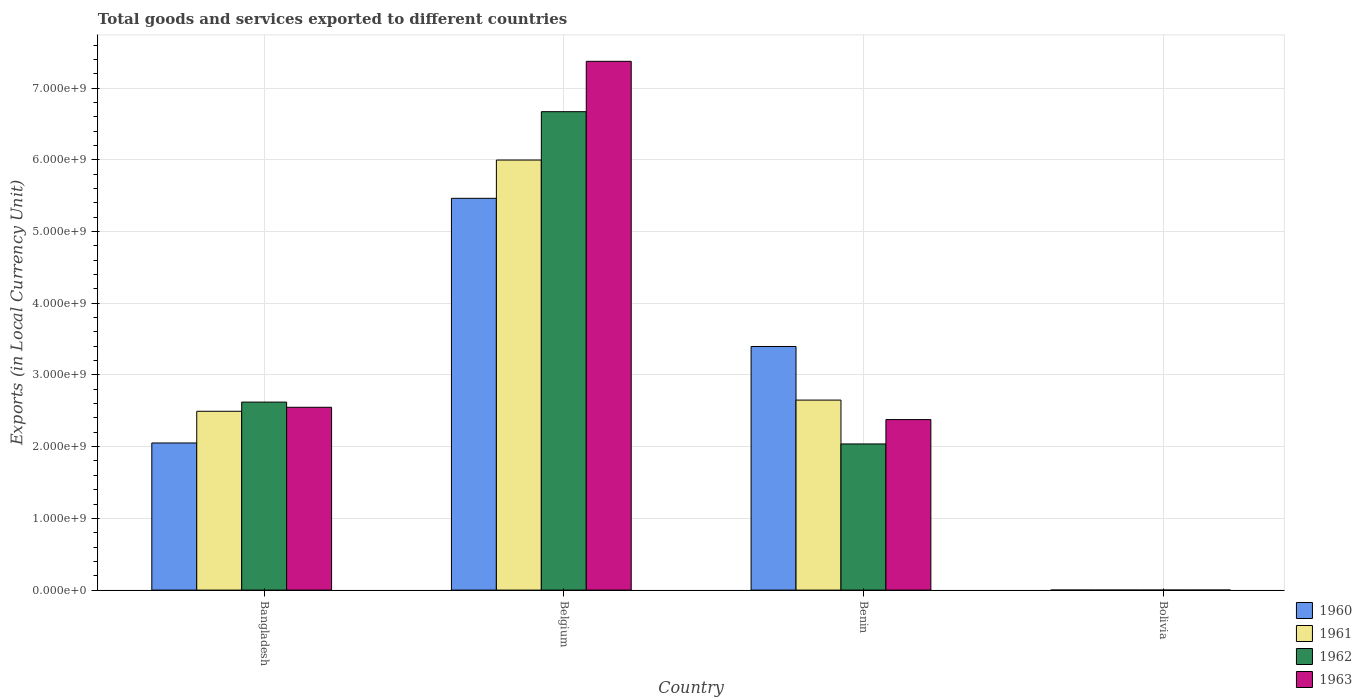How many groups of bars are there?
Your answer should be very brief. 4. Are the number of bars per tick equal to the number of legend labels?
Ensure brevity in your answer.  Yes. Are the number of bars on each tick of the X-axis equal?
Provide a short and direct response. Yes. How many bars are there on the 3rd tick from the left?
Make the answer very short. 4. In how many cases, is the number of bars for a given country not equal to the number of legend labels?
Keep it short and to the point. 0. What is the Amount of goods and services exports in 1960 in Bangladesh?
Provide a short and direct response. 2.05e+09. Across all countries, what is the maximum Amount of goods and services exports in 1962?
Your answer should be compact. 6.67e+09. Across all countries, what is the minimum Amount of goods and services exports in 1961?
Offer a very short reply. 1000. In which country was the Amount of goods and services exports in 1963 minimum?
Make the answer very short. Bolivia. What is the total Amount of goods and services exports in 1962 in the graph?
Provide a succinct answer. 1.13e+1. What is the difference between the Amount of goods and services exports in 1962 in Benin and that in Bolivia?
Your answer should be very brief. 2.04e+09. What is the difference between the Amount of goods and services exports in 1961 in Benin and the Amount of goods and services exports in 1960 in Bangladesh?
Your answer should be compact. 5.98e+08. What is the average Amount of goods and services exports in 1961 per country?
Keep it short and to the point. 2.78e+09. What is the difference between the Amount of goods and services exports of/in 1961 and Amount of goods and services exports of/in 1960 in Bangladesh?
Give a very brief answer. 4.42e+08. In how many countries, is the Amount of goods and services exports in 1961 greater than 4200000000 LCU?
Ensure brevity in your answer.  1. What is the ratio of the Amount of goods and services exports in 1963 in Benin to that in Bolivia?
Provide a short and direct response. 1.98e+06. Is the Amount of goods and services exports in 1960 in Belgium less than that in Bolivia?
Your answer should be compact. No. What is the difference between the highest and the second highest Amount of goods and services exports in 1962?
Your response must be concise. 4.63e+09. What is the difference between the highest and the lowest Amount of goods and services exports in 1960?
Give a very brief answer. 5.46e+09. Is it the case that in every country, the sum of the Amount of goods and services exports in 1961 and Amount of goods and services exports in 1962 is greater than the sum of Amount of goods and services exports in 1960 and Amount of goods and services exports in 1963?
Provide a succinct answer. No. What does the 2nd bar from the left in Bolivia represents?
Your answer should be very brief. 1961. Are all the bars in the graph horizontal?
Make the answer very short. No. Are the values on the major ticks of Y-axis written in scientific E-notation?
Your response must be concise. Yes. Does the graph contain any zero values?
Ensure brevity in your answer.  No. What is the title of the graph?
Your response must be concise. Total goods and services exported to different countries. What is the label or title of the Y-axis?
Make the answer very short. Exports (in Local Currency Unit). What is the Exports (in Local Currency Unit) of 1960 in Bangladesh?
Offer a very short reply. 2.05e+09. What is the Exports (in Local Currency Unit) of 1961 in Bangladesh?
Offer a terse response. 2.49e+09. What is the Exports (in Local Currency Unit) of 1962 in Bangladesh?
Offer a very short reply. 2.62e+09. What is the Exports (in Local Currency Unit) of 1963 in Bangladesh?
Provide a succinct answer. 2.55e+09. What is the Exports (in Local Currency Unit) in 1960 in Belgium?
Offer a terse response. 5.46e+09. What is the Exports (in Local Currency Unit) of 1961 in Belgium?
Keep it short and to the point. 6.00e+09. What is the Exports (in Local Currency Unit) in 1962 in Belgium?
Offer a very short reply. 6.67e+09. What is the Exports (in Local Currency Unit) in 1963 in Belgium?
Offer a very short reply. 7.37e+09. What is the Exports (in Local Currency Unit) of 1960 in Benin?
Your answer should be very brief. 3.40e+09. What is the Exports (in Local Currency Unit) of 1961 in Benin?
Give a very brief answer. 2.65e+09. What is the Exports (in Local Currency Unit) of 1962 in Benin?
Make the answer very short. 2.04e+09. What is the Exports (in Local Currency Unit) of 1963 in Benin?
Ensure brevity in your answer.  2.38e+09. What is the Exports (in Local Currency Unit) of 1960 in Bolivia?
Give a very brief answer. 900. What is the Exports (in Local Currency Unit) in 1962 in Bolivia?
Your response must be concise. 1000. What is the Exports (in Local Currency Unit) in 1963 in Bolivia?
Your answer should be very brief. 1200. Across all countries, what is the maximum Exports (in Local Currency Unit) of 1960?
Your answer should be very brief. 5.46e+09. Across all countries, what is the maximum Exports (in Local Currency Unit) of 1961?
Your response must be concise. 6.00e+09. Across all countries, what is the maximum Exports (in Local Currency Unit) in 1962?
Keep it short and to the point. 6.67e+09. Across all countries, what is the maximum Exports (in Local Currency Unit) in 1963?
Ensure brevity in your answer.  7.37e+09. Across all countries, what is the minimum Exports (in Local Currency Unit) of 1960?
Offer a very short reply. 900. Across all countries, what is the minimum Exports (in Local Currency Unit) of 1961?
Provide a succinct answer. 1000. Across all countries, what is the minimum Exports (in Local Currency Unit) in 1962?
Provide a succinct answer. 1000. Across all countries, what is the minimum Exports (in Local Currency Unit) in 1963?
Your answer should be compact. 1200. What is the total Exports (in Local Currency Unit) in 1960 in the graph?
Give a very brief answer. 1.09e+1. What is the total Exports (in Local Currency Unit) in 1961 in the graph?
Offer a terse response. 1.11e+1. What is the total Exports (in Local Currency Unit) of 1962 in the graph?
Your answer should be very brief. 1.13e+1. What is the total Exports (in Local Currency Unit) in 1963 in the graph?
Your response must be concise. 1.23e+1. What is the difference between the Exports (in Local Currency Unit) of 1960 in Bangladesh and that in Belgium?
Your response must be concise. -3.41e+09. What is the difference between the Exports (in Local Currency Unit) in 1961 in Bangladesh and that in Belgium?
Keep it short and to the point. -3.50e+09. What is the difference between the Exports (in Local Currency Unit) in 1962 in Bangladesh and that in Belgium?
Your answer should be compact. -4.05e+09. What is the difference between the Exports (in Local Currency Unit) in 1963 in Bangladesh and that in Belgium?
Offer a very short reply. -4.82e+09. What is the difference between the Exports (in Local Currency Unit) in 1960 in Bangladesh and that in Benin?
Offer a terse response. -1.35e+09. What is the difference between the Exports (in Local Currency Unit) of 1961 in Bangladesh and that in Benin?
Provide a short and direct response. -1.56e+08. What is the difference between the Exports (in Local Currency Unit) in 1962 in Bangladesh and that in Benin?
Your answer should be compact. 5.83e+08. What is the difference between the Exports (in Local Currency Unit) in 1963 in Bangladesh and that in Benin?
Keep it short and to the point. 1.72e+08. What is the difference between the Exports (in Local Currency Unit) of 1960 in Bangladesh and that in Bolivia?
Provide a short and direct response. 2.05e+09. What is the difference between the Exports (in Local Currency Unit) of 1961 in Bangladesh and that in Bolivia?
Your answer should be very brief. 2.49e+09. What is the difference between the Exports (in Local Currency Unit) in 1962 in Bangladesh and that in Bolivia?
Offer a very short reply. 2.62e+09. What is the difference between the Exports (in Local Currency Unit) of 1963 in Bangladesh and that in Bolivia?
Your answer should be compact. 2.55e+09. What is the difference between the Exports (in Local Currency Unit) of 1960 in Belgium and that in Benin?
Your answer should be compact. 2.07e+09. What is the difference between the Exports (in Local Currency Unit) in 1961 in Belgium and that in Benin?
Provide a succinct answer. 3.35e+09. What is the difference between the Exports (in Local Currency Unit) of 1962 in Belgium and that in Benin?
Offer a terse response. 4.63e+09. What is the difference between the Exports (in Local Currency Unit) of 1963 in Belgium and that in Benin?
Your response must be concise. 5.00e+09. What is the difference between the Exports (in Local Currency Unit) of 1960 in Belgium and that in Bolivia?
Keep it short and to the point. 5.46e+09. What is the difference between the Exports (in Local Currency Unit) in 1961 in Belgium and that in Bolivia?
Your answer should be very brief. 6.00e+09. What is the difference between the Exports (in Local Currency Unit) in 1962 in Belgium and that in Bolivia?
Make the answer very short. 6.67e+09. What is the difference between the Exports (in Local Currency Unit) in 1963 in Belgium and that in Bolivia?
Your answer should be compact. 7.37e+09. What is the difference between the Exports (in Local Currency Unit) in 1960 in Benin and that in Bolivia?
Provide a short and direct response. 3.40e+09. What is the difference between the Exports (in Local Currency Unit) in 1961 in Benin and that in Bolivia?
Make the answer very short. 2.65e+09. What is the difference between the Exports (in Local Currency Unit) of 1962 in Benin and that in Bolivia?
Offer a terse response. 2.04e+09. What is the difference between the Exports (in Local Currency Unit) of 1963 in Benin and that in Bolivia?
Offer a terse response. 2.38e+09. What is the difference between the Exports (in Local Currency Unit) in 1960 in Bangladesh and the Exports (in Local Currency Unit) in 1961 in Belgium?
Give a very brief answer. -3.94e+09. What is the difference between the Exports (in Local Currency Unit) of 1960 in Bangladesh and the Exports (in Local Currency Unit) of 1962 in Belgium?
Your answer should be very brief. -4.62e+09. What is the difference between the Exports (in Local Currency Unit) in 1960 in Bangladesh and the Exports (in Local Currency Unit) in 1963 in Belgium?
Provide a succinct answer. -5.32e+09. What is the difference between the Exports (in Local Currency Unit) in 1961 in Bangladesh and the Exports (in Local Currency Unit) in 1962 in Belgium?
Ensure brevity in your answer.  -4.18e+09. What is the difference between the Exports (in Local Currency Unit) of 1961 in Bangladesh and the Exports (in Local Currency Unit) of 1963 in Belgium?
Your response must be concise. -4.88e+09. What is the difference between the Exports (in Local Currency Unit) in 1962 in Bangladesh and the Exports (in Local Currency Unit) in 1963 in Belgium?
Give a very brief answer. -4.75e+09. What is the difference between the Exports (in Local Currency Unit) of 1960 in Bangladesh and the Exports (in Local Currency Unit) of 1961 in Benin?
Make the answer very short. -5.98e+08. What is the difference between the Exports (in Local Currency Unit) of 1960 in Bangladesh and the Exports (in Local Currency Unit) of 1962 in Benin?
Make the answer very short. 1.34e+07. What is the difference between the Exports (in Local Currency Unit) of 1960 in Bangladesh and the Exports (in Local Currency Unit) of 1963 in Benin?
Your answer should be compact. -3.26e+08. What is the difference between the Exports (in Local Currency Unit) in 1961 in Bangladesh and the Exports (in Local Currency Unit) in 1962 in Benin?
Keep it short and to the point. 4.55e+08. What is the difference between the Exports (in Local Currency Unit) of 1961 in Bangladesh and the Exports (in Local Currency Unit) of 1963 in Benin?
Ensure brevity in your answer.  1.16e+08. What is the difference between the Exports (in Local Currency Unit) in 1962 in Bangladesh and the Exports (in Local Currency Unit) in 1963 in Benin?
Your response must be concise. 2.44e+08. What is the difference between the Exports (in Local Currency Unit) of 1960 in Bangladesh and the Exports (in Local Currency Unit) of 1961 in Bolivia?
Ensure brevity in your answer.  2.05e+09. What is the difference between the Exports (in Local Currency Unit) in 1960 in Bangladesh and the Exports (in Local Currency Unit) in 1962 in Bolivia?
Your response must be concise. 2.05e+09. What is the difference between the Exports (in Local Currency Unit) in 1960 in Bangladesh and the Exports (in Local Currency Unit) in 1963 in Bolivia?
Offer a terse response. 2.05e+09. What is the difference between the Exports (in Local Currency Unit) of 1961 in Bangladesh and the Exports (in Local Currency Unit) of 1962 in Bolivia?
Keep it short and to the point. 2.49e+09. What is the difference between the Exports (in Local Currency Unit) of 1961 in Bangladesh and the Exports (in Local Currency Unit) of 1963 in Bolivia?
Your answer should be very brief. 2.49e+09. What is the difference between the Exports (in Local Currency Unit) of 1962 in Bangladesh and the Exports (in Local Currency Unit) of 1963 in Bolivia?
Make the answer very short. 2.62e+09. What is the difference between the Exports (in Local Currency Unit) in 1960 in Belgium and the Exports (in Local Currency Unit) in 1961 in Benin?
Your answer should be very brief. 2.81e+09. What is the difference between the Exports (in Local Currency Unit) in 1960 in Belgium and the Exports (in Local Currency Unit) in 1962 in Benin?
Offer a very short reply. 3.42e+09. What is the difference between the Exports (in Local Currency Unit) in 1960 in Belgium and the Exports (in Local Currency Unit) in 1963 in Benin?
Ensure brevity in your answer.  3.08e+09. What is the difference between the Exports (in Local Currency Unit) of 1961 in Belgium and the Exports (in Local Currency Unit) of 1962 in Benin?
Make the answer very short. 3.96e+09. What is the difference between the Exports (in Local Currency Unit) of 1961 in Belgium and the Exports (in Local Currency Unit) of 1963 in Benin?
Give a very brief answer. 3.62e+09. What is the difference between the Exports (in Local Currency Unit) of 1962 in Belgium and the Exports (in Local Currency Unit) of 1963 in Benin?
Provide a succinct answer. 4.29e+09. What is the difference between the Exports (in Local Currency Unit) in 1960 in Belgium and the Exports (in Local Currency Unit) in 1961 in Bolivia?
Your answer should be compact. 5.46e+09. What is the difference between the Exports (in Local Currency Unit) of 1960 in Belgium and the Exports (in Local Currency Unit) of 1962 in Bolivia?
Make the answer very short. 5.46e+09. What is the difference between the Exports (in Local Currency Unit) of 1960 in Belgium and the Exports (in Local Currency Unit) of 1963 in Bolivia?
Offer a terse response. 5.46e+09. What is the difference between the Exports (in Local Currency Unit) in 1961 in Belgium and the Exports (in Local Currency Unit) in 1962 in Bolivia?
Offer a very short reply. 6.00e+09. What is the difference between the Exports (in Local Currency Unit) in 1961 in Belgium and the Exports (in Local Currency Unit) in 1963 in Bolivia?
Give a very brief answer. 6.00e+09. What is the difference between the Exports (in Local Currency Unit) in 1962 in Belgium and the Exports (in Local Currency Unit) in 1963 in Bolivia?
Your response must be concise. 6.67e+09. What is the difference between the Exports (in Local Currency Unit) of 1960 in Benin and the Exports (in Local Currency Unit) of 1961 in Bolivia?
Provide a succinct answer. 3.40e+09. What is the difference between the Exports (in Local Currency Unit) of 1960 in Benin and the Exports (in Local Currency Unit) of 1962 in Bolivia?
Give a very brief answer. 3.40e+09. What is the difference between the Exports (in Local Currency Unit) in 1960 in Benin and the Exports (in Local Currency Unit) in 1963 in Bolivia?
Ensure brevity in your answer.  3.40e+09. What is the difference between the Exports (in Local Currency Unit) in 1961 in Benin and the Exports (in Local Currency Unit) in 1962 in Bolivia?
Make the answer very short. 2.65e+09. What is the difference between the Exports (in Local Currency Unit) of 1961 in Benin and the Exports (in Local Currency Unit) of 1963 in Bolivia?
Your answer should be very brief. 2.65e+09. What is the difference between the Exports (in Local Currency Unit) in 1962 in Benin and the Exports (in Local Currency Unit) in 1963 in Bolivia?
Provide a succinct answer. 2.04e+09. What is the average Exports (in Local Currency Unit) of 1960 per country?
Your answer should be very brief. 2.73e+09. What is the average Exports (in Local Currency Unit) of 1961 per country?
Provide a short and direct response. 2.78e+09. What is the average Exports (in Local Currency Unit) of 1962 per country?
Your response must be concise. 2.83e+09. What is the average Exports (in Local Currency Unit) of 1963 per country?
Give a very brief answer. 3.07e+09. What is the difference between the Exports (in Local Currency Unit) in 1960 and Exports (in Local Currency Unit) in 1961 in Bangladesh?
Give a very brief answer. -4.42e+08. What is the difference between the Exports (in Local Currency Unit) of 1960 and Exports (in Local Currency Unit) of 1962 in Bangladesh?
Make the answer very short. -5.70e+08. What is the difference between the Exports (in Local Currency Unit) of 1960 and Exports (in Local Currency Unit) of 1963 in Bangladesh?
Provide a succinct answer. -4.98e+08. What is the difference between the Exports (in Local Currency Unit) of 1961 and Exports (in Local Currency Unit) of 1962 in Bangladesh?
Ensure brevity in your answer.  -1.28e+08. What is the difference between the Exports (in Local Currency Unit) of 1961 and Exports (in Local Currency Unit) of 1963 in Bangladesh?
Keep it short and to the point. -5.58e+07. What is the difference between the Exports (in Local Currency Unit) of 1962 and Exports (in Local Currency Unit) of 1963 in Bangladesh?
Your response must be concise. 7.21e+07. What is the difference between the Exports (in Local Currency Unit) in 1960 and Exports (in Local Currency Unit) in 1961 in Belgium?
Your response must be concise. -5.34e+08. What is the difference between the Exports (in Local Currency Unit) of 1960 and Exports (in Local Currency Unit) of 1962 in Belgium?
Give a very brief answer. -1.21e+09. What is the difference between the Exports (in Local Currency Unit) of 1960 and Exports (in Local Currency Unit) of 1963 in Belgium?
Keep it short and to the point. -1.91e+09. What is the difference between the Exports (in Local Currency Unit) of 1961 and Exports (in Local Currency Unit) of 1962 in Belgium?
Ensure brevity in your answer.  -6.74e+08. What is the difference between the Exports (in Local Currency Unit) of 1961 and Exports (in Local Currency Unit) of 1963 in Belgium?
Offer a terse response. -1.38e+09. What is the difference between the Exports (in Local Currency Unit) of 1962 and Exports (in Local Currency Unit) of 1963 in Belgium?
Your answer should be very brief. -7.02e+08. What is the difference between the Exports (in Local Currency Unit) of 1960 and Exports (in Local Currency Unit) of 1961 in Benin?
Offer a very short reply. 7.47e+08. What is the difference between the Exports (in Local Currency Unit) of 1960 and Exports (in Local Currency Unit) of 1962 in Benin?
Your response must be concise. 1.36e+09. What is the difference between the Exports (in Local Currency Unit) in 1960 and Exports (in Local Currency Unit) in 1963 in Benin?
Keep it short and to the point. 1.02e+09. What is the difference between the Exports (in Local Currency Unit) in 1961 and Exports (in Local Currency Unit) in 1962 in Benin?
Make the answer very short. 6.11e+08. What is the difference between the Exports (in Local Currency Unit) of 1961 and Exports (in Local Currency Unit) of 1963 in Benin?
Ensure brevity in your answer.  2.72e+08. What is the difference between the Exports (in Local Currency Unit) in 1962 and Exports (in Local Currency Unit) in 1963 in Benin?
Make the answer very short. -3.40e+08. What is the difference between the Exports (in Local Currency Unit) of 1960 and Exports (in Local Currency Unit) of 1961 in Bolivia?
Provide a succinct answer. -100. What is the difference between the Exports (in Local Currency Unit) in 1960 and Exports (in Local Currency Unit) in 1962 in Bolivia?
Your answer should be compact. -100. What is the difference between the Exports (in Local Currency Unit) in 1960 and Exports (in Local Currency Unit) in 1963 in Bolivia?
Provide a succinct answer. -300. What is the difference between the Exports (in Local Currency Unit) in 1961 and Exports (in Local Currency Unit) in 1963 in Bolivia?
Your answer should be very brief. -200. What is the difference between the Exports (in Local Currency Unit) in 1962 and Exports (in Local Currency Unit) in 1963 in Bolivia?
Offer a very short reply. -200. What is the ratio of the Exports (in Local Currency Unit) of 1960 in Bangladesh to that in Belgium?
Give a very brief answer. 0.38. What is the ratio of the Exports (in Local Currency Unit) in 1961 in Bangladesh to that in Belgium?
Your answer should be very brief. 0.42. What is the ratio of the Exports (in Local Currency Unit) in 1962 in Bangladesh to that in Belgium?
Make the answer very short. 0.39. What is the ratio of the Exports (in Local Currency Unit) of 1963 in Bangladesh to that in Belgium?
Provide a short and direct response. 0.35. What is the ratio of the Exports (in Local Currency Unit) in 1960 in Bangladesh to that in Benin?
Keep it short and to the point. 0.6. What is the ratio of the Exports (in Local Currency Unit) in 1961 in Bangladesh to that in Benin?
Your answer should be compact. 0.94. What is the ratio of the Exports (in Local Currency Unit) in 1962 in Bangladesh to that in Benin?
Provide a short and direct response. 1.29. What is the ratio of the Exports (in Local Currency Unit) in 1963 in Bangladesh to that in Benin?
Provide a short and direct response. 1.07. What is the ratio of the Exports (in Local Currency Unit) of 1960 in Bangladesh to that in Bolivia?
Your response must be concise. 2.28e+06. What is the ratio of the Exports (in Local Currency Unit) of 1961 in Bangladesh to that in Bolivia?
Provide a succinct answer. 2.49e+06. What is the ratio of the Exports (in Local Currency Unit) in 1962 in Bangladesh to that in Bolivia?
Offer a very short reply. 2.62e+06. What is the ratio of the Exports (in Local Currency Unit) in 1963 in Bangladesh to that in Bolivia?
Make the answer very short. 2.12e+06. What is the ratio of the Exports (in Local Currency Unit) in 1960 in Belgium to that in Benin?
Ensure brevity in your answer.  1.61. What is the ratio of the Exports (in Local Currency Unit) of 1961 in Belgium to that in Benin?
Ensure brevity in your answer.  2.26. What is the ratio of the Exports (in Local Currency Unit) in 1962 in Belgium to that in Benin?
Your answer should be compact. 3.27. What is the ratio of the Exports (in Local Currency Unit) in 1963 in Belgium to that in Benin?
Give a very brief answer. 3.1. What is the ratio of the Exports (in Local Currency Unit) in 1960 in Belgium to that in Bolivia?
Your answer should be very brief. 6.07e+06. What is the ratio of the Exports (in Local Currency Unit) in 1961 in Belgium to that in Bolivia?
Keep it short and to the point. 6.00e+06. What is the ratio of the Exports (in Local Currency Unit) in 1962 in Belgium to that in Bolivia?
Keep it short and to the point. 6.67e+06. What is the ratio of the Exports (in Local Currency Unit) of 1963 in Belgium to that in Bolivia?
Keep it short and to the point. 6.14e+06. What is the ratio of the Exports (in Local Currency Unit) in 1960 in Benin to that in Bolivia?
Ensure brevity in your answer.  3.77e+06. What is the ratio of the Exports (in Local Currency Unit) of 1961 in Benin to that in Bolivia?
Keep it short and to the point. 2.65e+06. What is the ratio of the Exports (in Local Currency Unit) in 1962 in Benin to that in Bolivia?
Keep it short and to the point. 2.04e+06. What is the ratio of the Exports (in Local Currency Unit) of 1963 in Benin to that in Bolivia?
Provide a short and direct response. 1.98e+06. What is the difference between the highest and the second highest Exports (in Local Currency Unit) in 1960?
Your response must be concise. 2.07e+09. What is the difference between the highest and the second highest Exports (in Local Currency Unit) of 1961?
Give a very brief answer. 3.35e+09. What is the difference between the highest and the second highest Exports (in Local Currency Unit) of 1962?
Give a very brief answer. 4.05e+09. What is the difference between the highest and the second highest Exports (in Local Currency Unit) of 1963?
Provide a short and direct response. 4.82e+09. What is the difference between the highest and the lowest Exports (in Local Currency Unit) in 1960?
Your answer should be compact. 5.46e+09. What is the difference between the highest and the lowest Exports (in Local Currency Unit) of 1961?
Offer a terse response. 6.00e+09. What is the difference between the highest and the lowest Exports (in Local Currency Unit) in 1962?
Offer a terse response. 6.67e+09. What is the difference between the highest and the lowest Exports (in Local Currency Unit) of 1963?
Make the answer very short. 7.37e+09. 